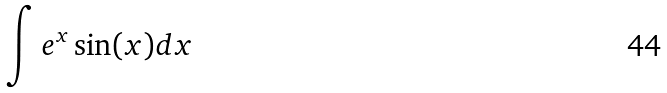Convert formula to latex. <formula><loc_0><loc_0><loc_500><loc_500>\int e ^ { x } \sin ( x ) d x</formula> 